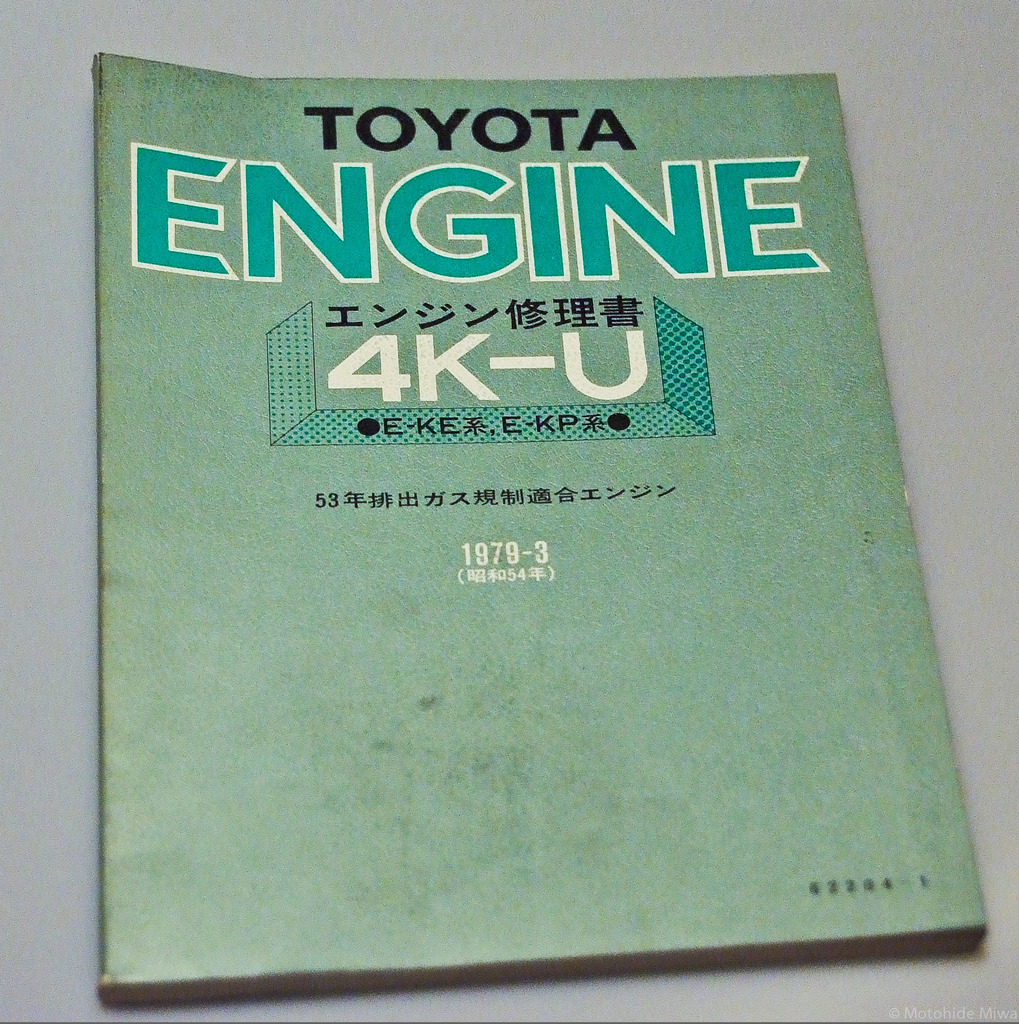What are the technical specifications of the 4K-U engine mentioned in this manual? The 4K-U engine, as detailed in the manual, is a carbureted 1.3-liter engine renowned for its simplicity and durability. It features a SOHC (Single Overhead Camshaft) design and was primarily used in certain Corolla and Starlet models. The engine is noted for good fuel economy and straightforward maintenance, which contributed to its popularity. 